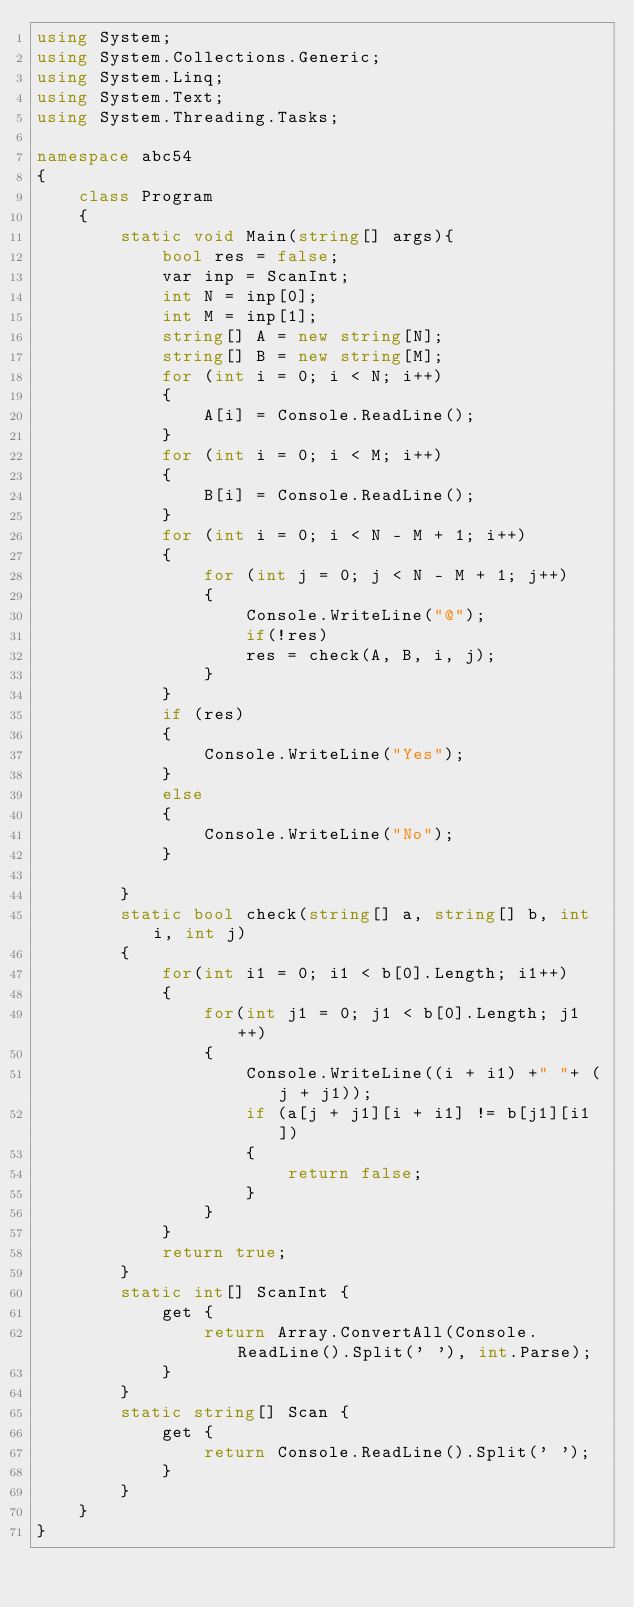Convert code to text. <code><loc_0><loc_0><loc_500><loc_500><_C#_>using System;
using System.Collections.Generic;
using System.Linq;
using System.Text;
using System.Threading.Tasks;

namespace abc54
{
    class Program
    {
        static void Main(string[] args){
            bool res = false;
            var inp = ScanInt;
            int N = inp[0];
            int M = inp[1];
            string[] A = new string[N];
            string[] B = new string[M];
            for (int i = 0; i < N; i++)
            {
                A[i] = Console.ReadLine();
            }
            for (int i = 0; i < M; i++)
            {
                B[i] = Console.ReadLine();
            }  
            for (int i = 0; i < N - M + 1; i++)
            {
                for (int j = 0; j < N - M + 1; j++)
                {
                    Console.WriteLine("@");
                    if(!res)
                    res = check(A, B, i, j);
                }
            }
            if (res)
            {
                Console.WriteLine("Yes");
            }
            else
            {
                Console.WriteLine("No");
            }

        }
        static bool check(string[] a, string[] b, int i, int j)
        {
            for(int i1 = 0; i1 < b[0].Length; i1++)
            {
                for(int j1 = 0; j1 < b[0].Length; j1++)
                {
                    Console.WriteLine((i + i1) +" "+ (j + j1));
                    if (a[j + j1][i + i1] != b[j1][i1])
                    {
                        return false;
                    }
                }
            }
            return true;
        }
        static int[] ScanInt {
            get {
                return Array.ConvertAll(Console.ReadLine().Split(' '), int.Parse);
            }
        }
        static string[] Scan {
            get {
                return Console.ReadLine().Split(' ');
            }
        }
    }
}
</code> 